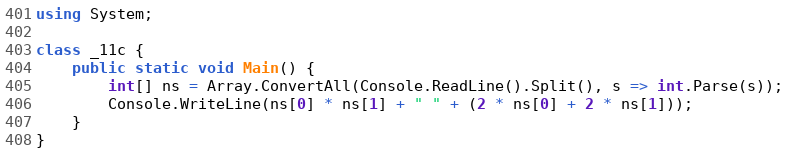Convert code to text. <code><loc_0><loc_0><loc_500><loc_500><_C#_>using System;

class _11c {
    public static void Main() {
        int[] ns = Array.ConvertAll(Console.ReadLine().Split(), s => int.Parse(s));
        Console.WriteLine(ns[0] * ns[1] + " " + (2 * ns[0] + 2 * ns[1]));
    }
}</code> 